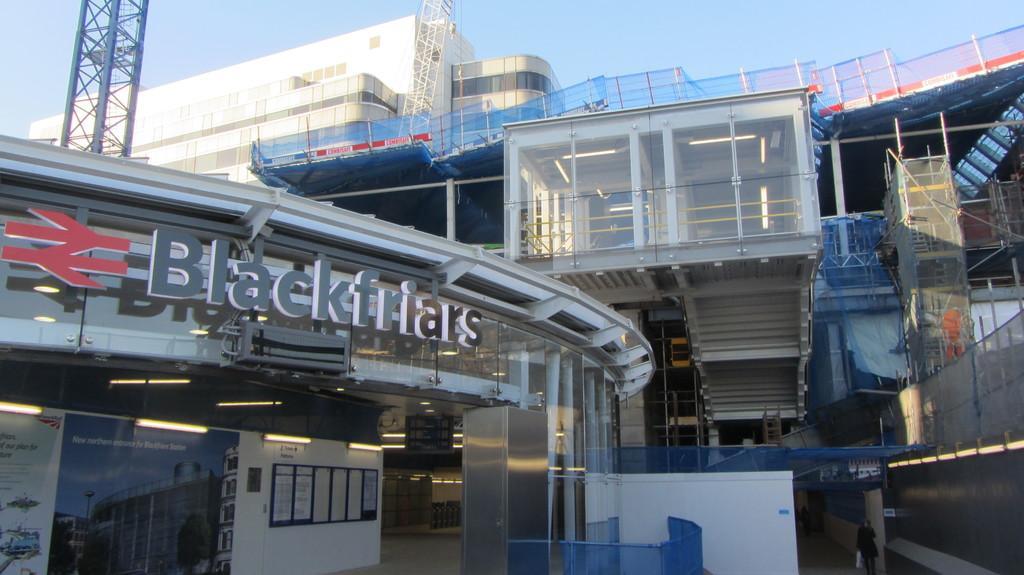In one or two sentences, can you explain what this image depicts? In this image we can see many buildings. There are few advertising boards in the image. There are few objects in the image. There is a notice board in the image. There are many posters on the notice board in the image. We can see the sky in the image. 